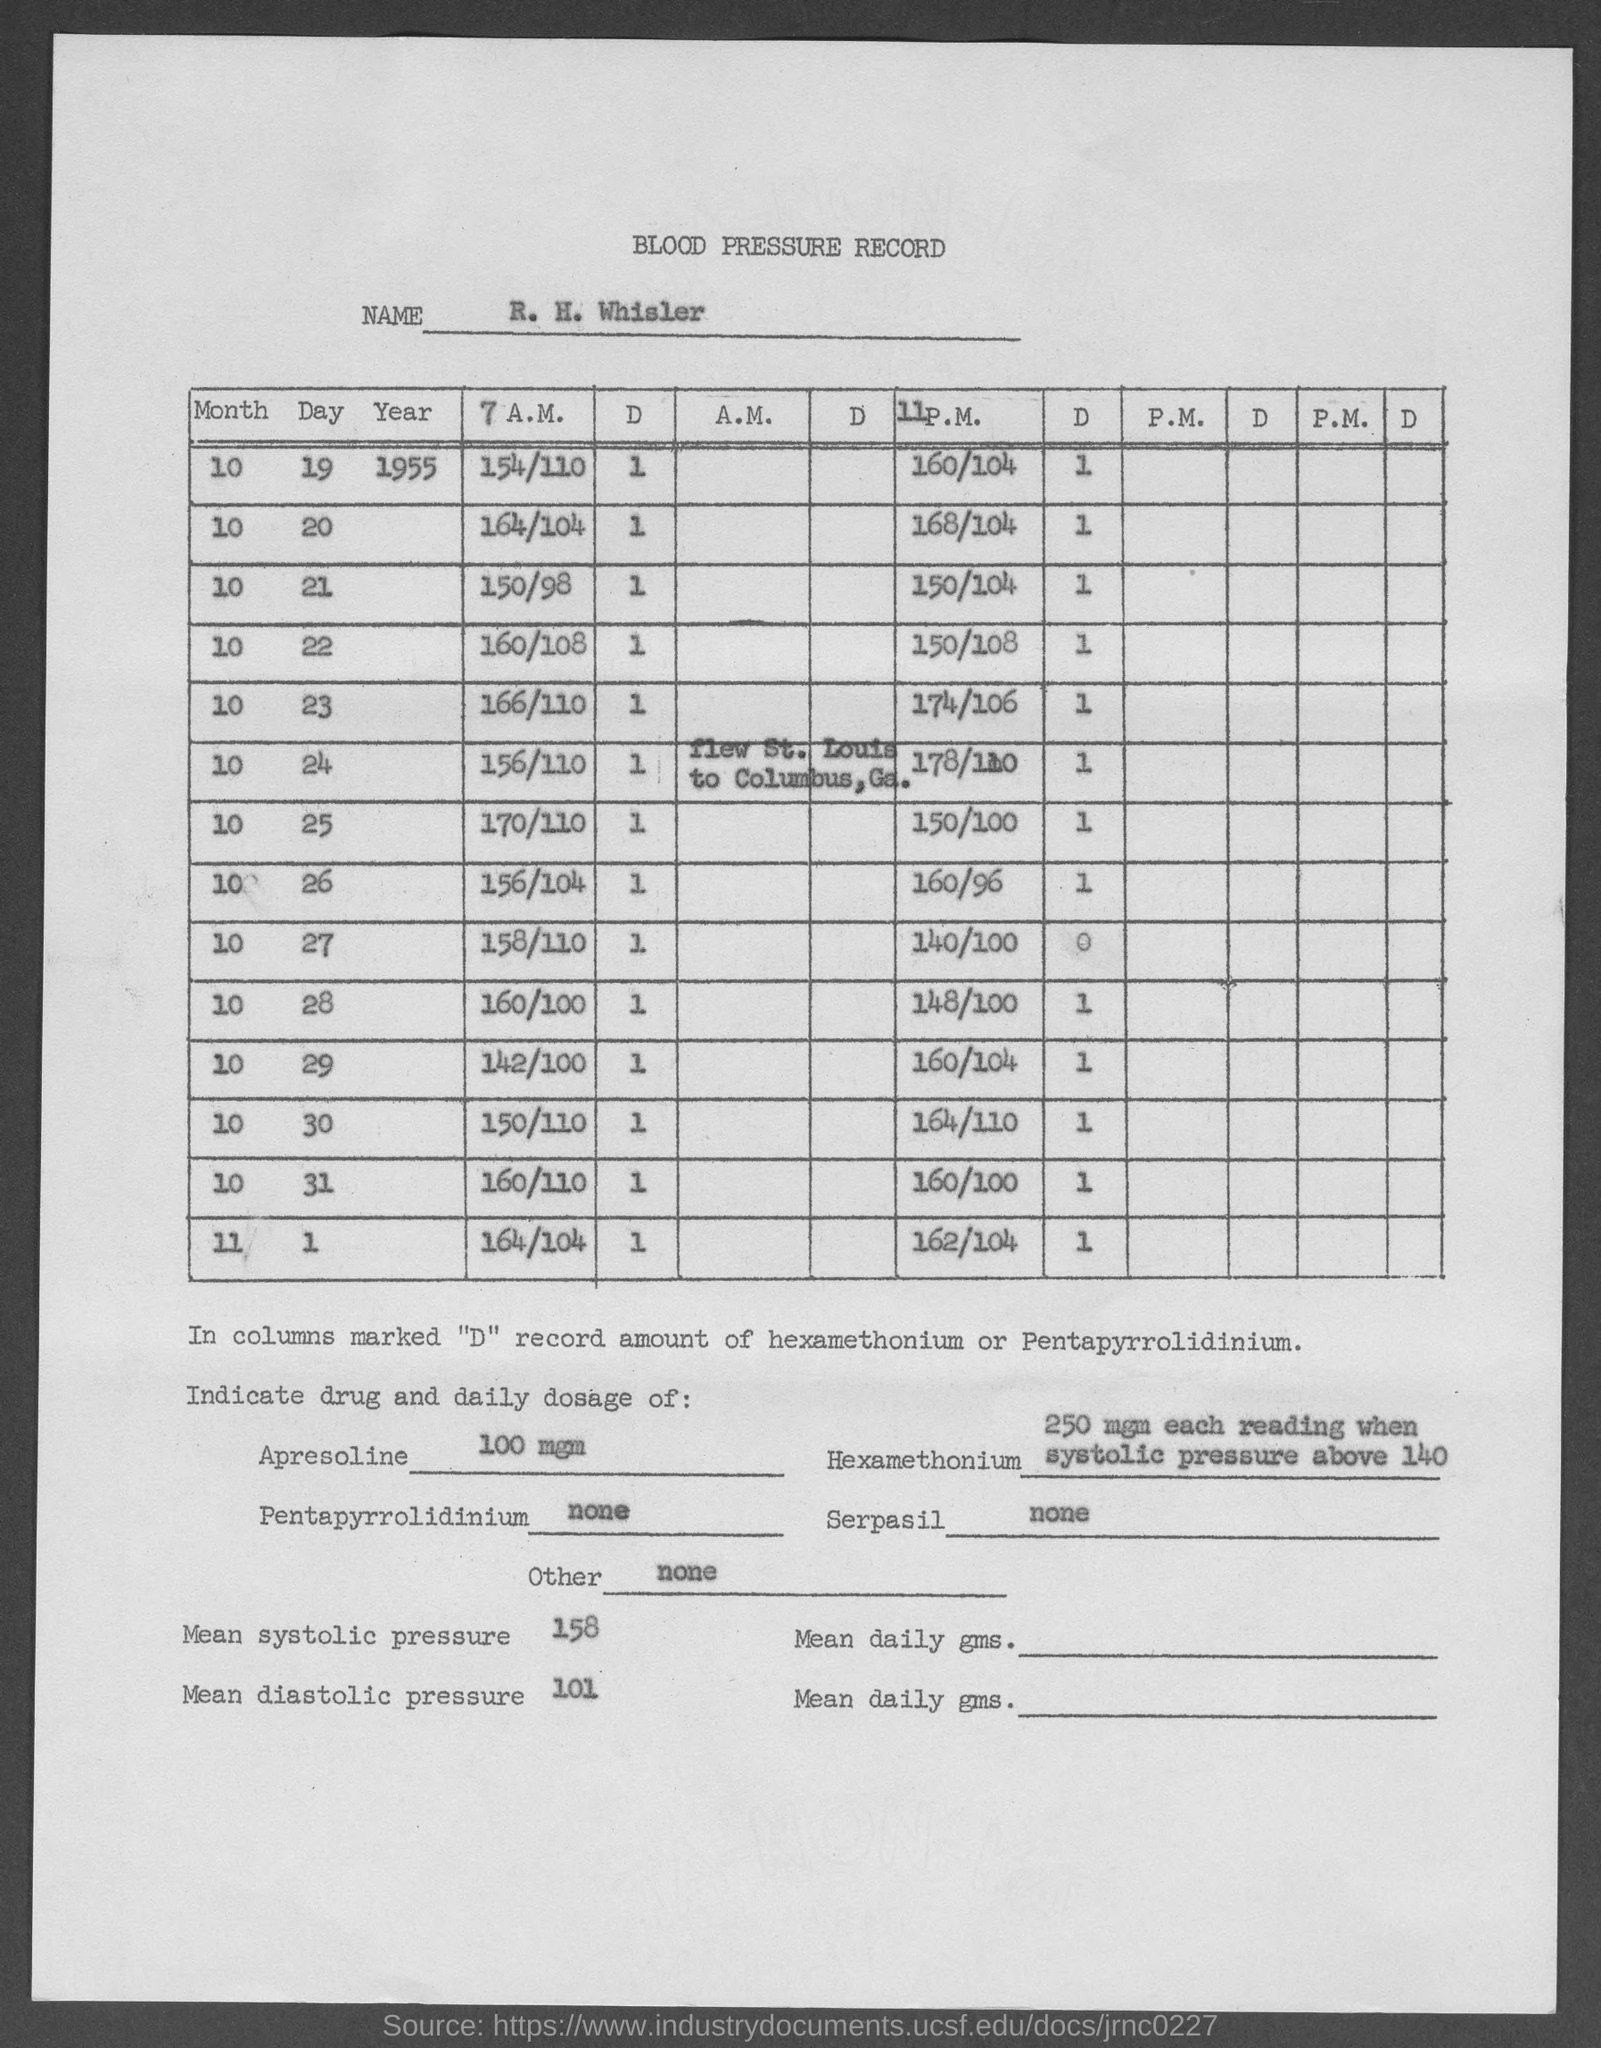What is the daily dosage of apresoline ?
Provide a succinct answer. 100 mgm. What is mean systolic pressure ?
Offer a terse response. 158. What is mean diastolic pressure ?
Offer a very short reply. 101. What is the daily dosage of serpasil ?
Give a very brief answer. None. What is the daily dosage of pentapyrrolidinium?
Your answer should be compact. None. 